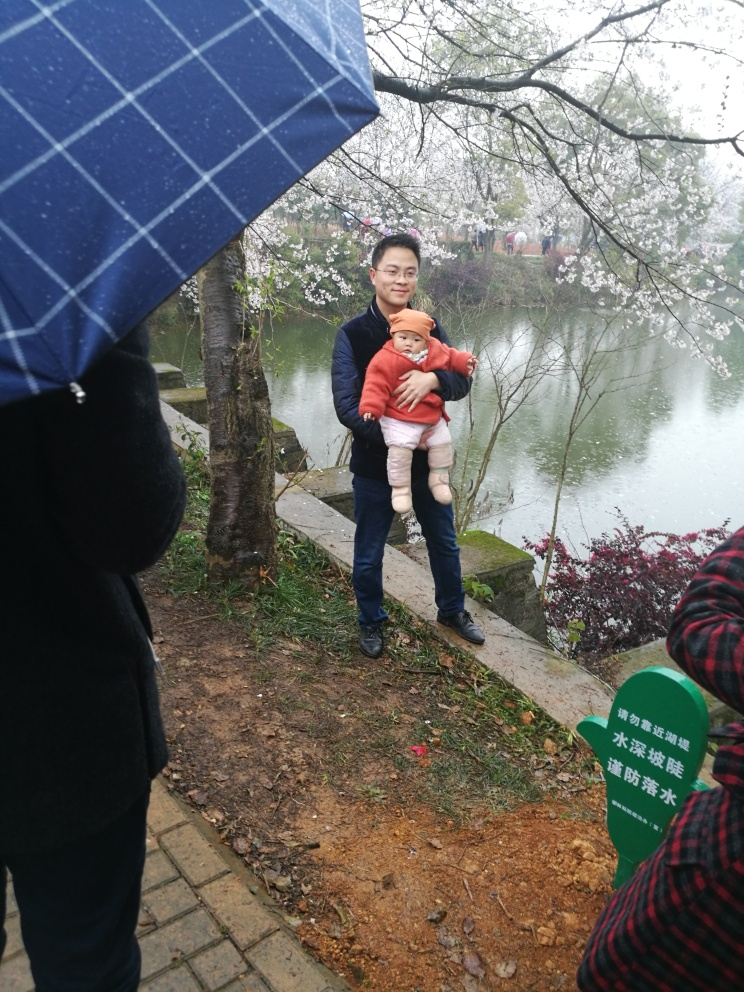How would you rate the composition of the image?
A. Exceptional
B. Average
C. Excellent
D. Poor
Answer with the option's letter from the given choices directly. I would rate the composition of this image as Average, option B. The photo captures a candid moment between a person and a child, set against a natural background with cherry blossoms and a water body. However, the composition could be improved by focusing more on the subjects and using the rule of thirds to create a more dynamic and aesthetically pleasing image. 